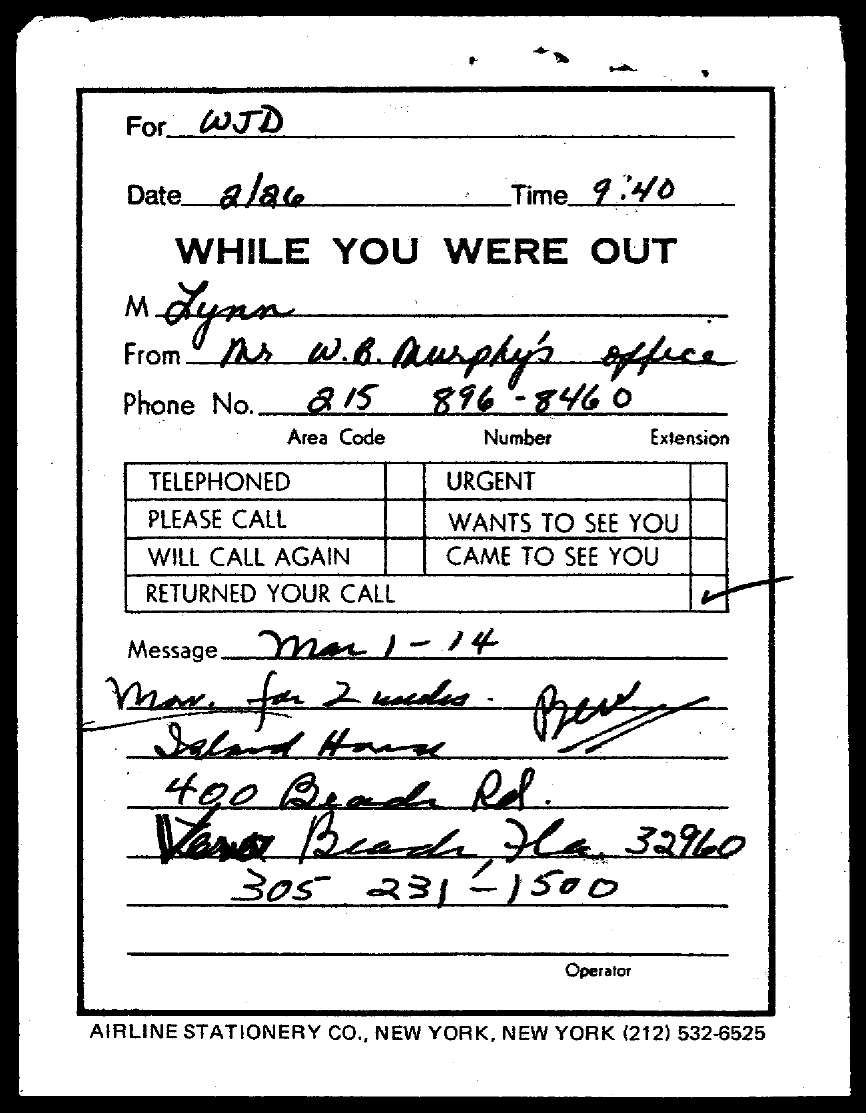Identify some key points in this picture. The phone number in the message is 305 231-1500. The phone number for Mr. W.B. Murphy's office is 215 896-8460. What is the date? Today is February 26th. The time is 9:40. The note is addressed to "To Whom is this note addressed to? 